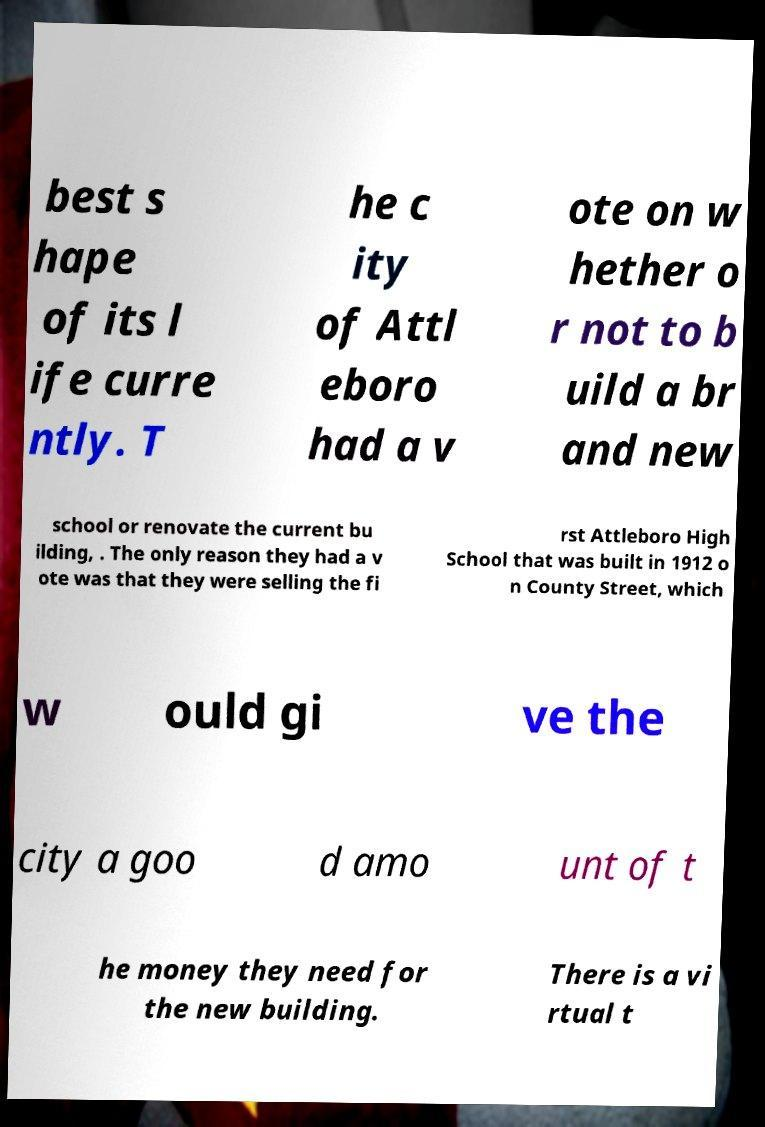Could you assist in decoding the text presented in this image and type it out clearly? best s hape of its l ife curre ntly. T he c ity of Attl eboro had a v ote on w hether o r not to b uild a br and new school or renovate the current bu ilding, . The only reason they had a v ote was that they were selling the fi rst Attleboro High School that was built in 1912 o n County Street, which w ould gi ve the city a goo d amo unt of t he money they need for the new building. There is a vi rtual t 